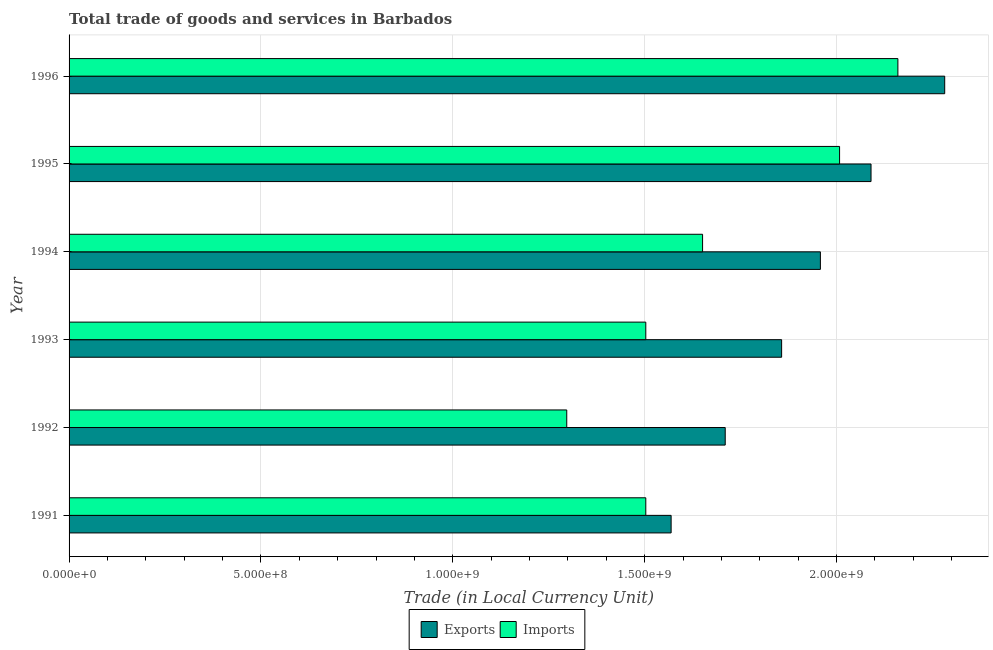How many groups of bars are there?
Offer a very short reply. 6. Are the number of bars per tick equal to the number of legend labels?
Your answer should be very brief. Yes. How many bars are there on the 1st tick from the top?
Give a very brief answer. 2. What is the label of the 3rd group of bars from the top?
Provide a short and direct response. 1994. In how many cases, is the number of bars for a given year not equal to the number of legend labels?
Make the answer very short. 0. What is the export of goods and services in 1993?
Your answer should be very brief. 1.86e+09. Across all years, what is the maximum imports of goods and services?
Give a very brief answer. 2.16e+09. Across all years, what is the minimum imports of goods and services?
Offer a very short reply. 1.30e+09. In which year was the export of goods and services maximum?
Give a very brief answer. 1996. In which year was the imports of goods and services minimum?
Keep it short and to the point. 1992. What is the total export of goods and services in the graph?
Your answer should be very brief. 1.15e+1. What is the difference between the imports of goods and services in 1991 and that in 1996?
Provide a short and direct response. -6.57e+08. What is the difference between the export of goods and services in 1992 and the imports of goods and services in 1996?
Provide a succinct answer. -4.50e+08. What is the average imports of goods and services per year?
Keep it short and to the point. 1.69e+09. In the year 1996, what is the difference between the imports of goods and services and export of goods and services?
Provide a succinct answer. -1.22e+08. In how many years, is the imports of goods and services greater than 2000000000 LCU?
Offer a terse response. 2. What is the ratio of the export of goods and services in 1991 to that in 1993?
Give a very brief answer. 0.84. What is the difference between the highest and the second highest export of goods and services?
Make the answer very short. 1.92e+08. What is the difference between the highest and the lowest export of goods and services?
Your answer should be compact. 7.13e+08. Is the sum of the export of goods and services in 1991 and 1995 greater than the maximum imports of goods and services across all years?
Your answer should be very brief. Yes. What does the 2nd bar from the top in 1992 represents?
Your answer should be compact. Exports. What does the 2nd bar from the bottom in 1995 represents?
Keep it short and to the point. Imports. Are all the bars in the graph horizontal?
Ensure brevity in your answer.  Yes. How many years are there in the graph?
Your response must be concise. 6. What is the difference between two consecutive major ticks on the X-axis?
Make the answer very short. 5.00e+08. Does the graph contain grids?
Ensure brevity in your answer.  Yes. Where does the legend appear in the graph?
Offer a terse response. Bottom center. How many legend labels are there?
Keep it short and to the point. 2. What is the title of the graph?
Provide a succinct answer. Total trade of goods and services in Barbados. Does "% of GNI" appear as one of the legend labels in the graph?
Your response must be concise. No. What is the label or title of the X-axis?
Make the answer very short. Trade (in Local Currency Unit). What is the label or title of the Y-axis?
Ensure brevity in your answer.  Year. What is the Trade (in Local Currency Unit) in Exports in 1991?
Give a very brief answer. 1.57e+09. What is the Trade (in Local Currency Unit) of Imports in 1991?
Provide a short and direct response. 1.50e+09. What is the Trade (in Local Currency Unit) in Exports in 1992?
Offer a terse response. 1.71e+09. What is the Trade (in Local Currency Unit) in Imports in 1992?
Give a very brief answer. 1.30e+09. What is the Trade (in Local Currency Unit) of Exports in 1993?
Ensure brevity in your answer.  1.86e+09. What is the Trade (in Local Currency Unit) in Imports in 1993?
Provide a short and direct response. 1.50e+09. What is the Trade (in Local Currency Unit) of Exports in 1994?
Your answer should be very brief. 1.96e+09. What is the Trade (in Local Currency Unit) of Imports in 1994?
Give a very brief answer. 1.65e+09. What is the Trade (in Local Currency Unit) of Exports in 1995?
Make the answer very short. 2.09e+09. What is the Trade (in Local Currency Unit) in Imports in 1995?
Provide a short and direct response. 2.01e+09. What is the Trade (in Local Currency Unit) of Exports in 1996?
Ensure brevity in your answer.  2.28e+09. What is the Trade (in Local Currency Unit) in Imports in 1996?
Offer a very short reply. 2.16e+09. Across all years, what is the maximum Trade (in Local Currency Unit) in Exports?
Your answer should be very brief. 2.28e+09. Across all years, what is the maximum Trade (in Local Currency Unit) of Imports?
Provide a succinct answer. 2.16e+09. Across all years, what is the minimum Trade (in Local Currency Unit) in Exports?
Your response must be concise. 1.57e+09. Across all years, what is the minimum Trade (in Local Currency Unit) in Imports?
Provide a short and direct response. 1.30e+09. What is the total Trade (in Local Currency Unit) of Exports in the graph?
Offer a very short reply. 1.15e+1. What is the total Trade (in Local Currency Unit) in Imports in the graph?
Provide a succinct answer. 1.01e+1. What is the difference between the Trade (in Local Currency Unit) of Exports in 1991 and that in 1992?
Offer a very short reply. -1.41e+08. What is the difference between the Trade (in Local Currency Unit) of Imports in 1991 and that in 1992?
Provide a short and direct response. 2.06e+08. What is the difference between the Trade (in Local Currency Unit) of Exports in 1991 and that in 1993?
Make the answer very short. -2.88e+08. What is the difference between the Trade (in Local Currency Unit) of Exports in 1991 and that in 1994?
Provide a short and direct response. -3.89e+08. What is the difference between the Trade (in Local Currency Unit) of Imports in 1991 and that in 1994?
Make the answer very short. -1.48e+08. What is the difference between the Trade (in Local Currency Unit) of Exports in 1991 and that in 1995?
Provide a short and direct response. -5.21e+08. What is the difference between the Trade (in Local Currency Unit) of Imports in 1991 and that in 1995?
Give a very brief answer. -5.05e+08. What is the difference between the Trade (in Local Currency Unit) in Exports in 1991 and that in 1996?
Make the answer very short. -7.13e+08. What is the difference between the Trade (in Local Currency Unit) in Imports in 1991 and that in 1996?
Give a very brief answer. -6.57e+08. What is the difference between the Trade (in Local Currency Unit) in Exports in 1992 and that in 1993?
Ensure brevity in your answer.  -1.47e+08. What is the difference between the Trade (in Local Currency Unit) of Imports in 1992 and that in 1993?
Ensure brevity in your answer.  -2.06e+08. What is the difference between the Trade (in Local Currency Unit) in Exports in 1992 and that in 1994?
Provide a short and direct response. -2.48e+08. What is the difference between the Trade (in Local Currency Unit) in Imports in 1992 and that in 1994?
Your answer should be very brief. -3.54e+08. What is the difference between the Trade (in Local Currency Unit) in Exports in 1992 and that in 1995?
Your response must be concise. -3.80e+08. What is the difference between the Trade (in Local Currency Unit) in Imports in 1992 and that in 1995?
Provide a succinct answer. -7.11e+08. What is the difference between the Trade (in Local Currency Unit) in Exports in 1992 and that in 1996?
Provide a succinct answer. -5.72e+08. What is the difference between the Trade (in Local Currency Unit) in Imports in 1992 and that in 1996?
Your answer should be compact. -8.63e+08. What is the difference between the Trade (in Local Currency Unit) in Exports in 1993 and that in 1994?
Provide a succinct answer. -1.01e+08. What is the difference between the Trade (in Local Currency Unit) of Imports in 1993 and that in 1994?
Your response must be concise. -1.48e+08. What is the difference between the Trade (in Local Currency Unit) in Exports in 1993 and that in 1995?
Your response must be concise. -2.33e+08. What is the difference between the Trade (in Local Currency Unit) of Imports in 1993 and that in 1995?
Give a very brief answer. -5.05e+08. What is the difference between the Trade (in Local Currency Unit) of Exports in 1993 and that in 1996?
Your response must be concise. -4.25e+08. What is the difference between the Trade (in Local Currency Unit) of Imports in 1993 and that in 1996?
Offer a very short reply. -6.57e+08. What is the difference between the Trade (in Local Currency Unit) of Exports in 1994 and that in 1995?
Offer a very short reply. -1.32e+08. What is the difference between the Trade (in Local Currency Unit) of Imports in 1994 and that in 1995?
Give a very brief answer. -3.57e+08. What is the difference between the Trade (in Local Currency Unit) of Exports in 1994 and that in 1996?
Offer a very short reply. -3.24e+08. What is the difference between the Trade (in Local Currency Unit) in Imports in 1994 and that in 1996?
Provide a succinct answer. -5.09e+08. What is the difference between the Trade (in Local Currency Unit) in Exports in 1995 and that in 1996?
Keep it short and to the point. -1.92e+08. What is the difference between the Trade (in Local Currency Unit) in Imports in 1995 and that in 1996?
Offer a terse response. -1.52e+08. What is the difference between the Trade (in Local Currency Unit) of Exports in 1991 and the Trade (in Local Currency Unit) of Imports in 1992?
Make the answer very short. 2.72e+08. What is the difference between the Trade (in Local Currency Unit) of Exports in 1991 and the Trade (in Local Currency Unit) of Imports in 1993?
Offer a terse response. 6.60e+07. What is the difference between the Trade (in Local Currency Unit) of Exports in 1991 and the Trade (in Local Currency Unit) of Imports in 1994?
Provide a short and direct response. -8.20e+07. What is the difference between the Trade (in Local Currency Unit) in Exports in 1991 and the Trade (in Local Currency Unit) in Imports in 1995?
Keep it short and to the point. -4.39e+08. What is the difference between the Trade (in Local Currency Unit) in Exports in 1991 and the Trade (in Local Currency Unit) in Imports in 1996?
Make the answer very short. -5.91e+08. What is the difference between the Trade (in Local Currency Unit) of Exports in 1992 and the Trade (in Local Currency Unit) of Imports in 1993?
Your response must be concise. 2.07e+08. What is the difference between the Trade (in Local Currency Unit) in Exports in 1992 and the Trade (in Local Currency Unit) in Imports in 1994?
Your answer should be very brief. 5.90e+07. What is the difference between the Trade (in Local Currency Unit) in Exports in 1992 and the Trade (in Local Currency Unit) in Imports in 1995?
Make the answer very short. -2.98e+08. What is the difference between the Trade (in Local Currency Unit) in Exports in 1992 and the Trade (in Local Currency Unit) in Imports in 1996?
Your answer should be compact. -4.50e+08. What is the difference between the Trade (in Local Currency Unit) in Exports in 1993 and the Trade (in Local Currency Unit) in Imports in 1994?
Your response must be concise. 2.06e+08. What is the difference between the Trade (in Local Currency Unit) of Exports in 1993 and the Trade (in Local Currency Unit) of Imports in 1995?
Your answer should be very brief. -1.51e+08. What is the difference between the Trade (in Local Currency Unit) of Exports in 1993 and the Trade (in Local Currency Unit) of Imports in 1996?
Provide a succinct answer. -3.03e+08. What is the difference between the Trade (in Local Currency Unit) in Exports in 1994 and the Trade (in Local Currency Unit) in Imports in 1995?
Ensure brevity in your answer.  -5.00e+07. What is the difference between the Trade (in Local Currency Unit) in Exports in 1994 and the Trade (in Local Currency Unit) in Imports in 1996?
Provide a succinct answer. -2.02e+08. What is the difference between the Trade (in Local Currency Unit) in Exports in 1995 and the Trade (in Local Currency Unit) in Imports in 1996?
Your answer should be compact. -7.00e+07. What is the average Trade (in Local Currency Unit) in Exports per year?
Your answer should be compact. 1.91e+09. What is the average Trade (in Local Currency Unit) in Imports per year?
Ensure brevity in your answer.  1.69e+09. In the year 1991, what is the difference between the Trade (in Local Currency Unit) in Exports and Trade (in Local Currency Unit) in Imports?
Your response must be concise. 6.60e+07. In the year 1992, what is the difference between the Trade (in Local Currency Unit) of Exports and Trade (in Local Currency Unit) of Imports?
Your response must be concise. 4.13e+08. In the year 1993, what is the difference between the Trade (in Local Currency Unit) of Exports and Trade (in Local Currency Unit) of Imports?
Give a very brief answer. 3.54e+08. In the year 1994, what is the difference between the Trade (in Local Currency Unit) in Exports and Trade (in Local Currency Unit) in Imports?
Offer a terse response. 3.07e+08. In the year 1995, what is the difference between the Trade (in Local Currency Unit) of Exports and Trade (in Local Currency Unit) of Imports?
Your answer should be compact. 8.20e+07. In the year 1996, what is the difference between the Trade (in Local Currency Unit) of Exports and Trade (in Local Currency Unit) of Imports?
Your response must be concise. 1.22e+08. What is the ratio of the Trade (in Local Currency Unit) in Exports in 1991 to that in 1992?
Offer a very short reply. 0.92. What is the ratio of the Trade (in Local Currency Unit) in Imports in 1991 to that in 1992?
Offer a terse response. 1.16. What is the ratio of the Trade (in Local Currency Unit) in Exports in 1991 to that in 1993?
Your answer should be compact. 0.84. What is the ratio of the Trade (in Local Currency Unit) in Imports in 1991 to that in 1993?
Give a very brief answer. 1. What is the ratio of the Trade (in Local Currency Unit) of Exports in 1991 to that in 1994?
Your answer should be compact. 0.8. What is the ratio of the Trade (in Local Currency Unit) of Imports in 1991 to that in 1994?
Provide a succinct answer. 0.91. What is the ratio of the Trade (in Local Currency Unit) of Exports in 1991 to that in 1995?
Your answer should be compact. 0.75. What is the ratio of the Trade (in Local Currency Unit) of Imports in 1991 to that in 1995?
Your answer should be compact. 0.75. What is the ratio of the Trade (in Local Currency Unit) of Exports in 1991 to that in 1996?
Your answer should be very brief. 0.69. What is the ratio of the Trade (in Local Currency Unit) of Imports in 1991 to that in 1996?
Your answer should be compact. 0.7. What is the ratio of the Trade (in Local Currency Unit) in Exports in 1992 to that in 1993?
Your answer should be compact. 0.92. What is the ratio of the Trade (in Local Currency Unit) of Imports in 1992 to that in 1993?
Offer a very short reply. 0.86. What is the ratio of the Trade (in Local Currency Unit) in Exports in 1992 to that in 1994?
Keep it short and to the point. 0.87. What is the ratio of the Trade (in Local Currency Unit) of Imports in 1992 to that in 1994?
Your answer should be very brief. 0.79. What is the ratio of the Trade (in Local Currency Unit) in Exports in 1992 to that in 1995?
Offer a very short reply. 0.82. What is the ratio of the Trade (in Local Currency Unit) in Imports in 1992 to that in 1995?
Provide a succinct answer. 0.65. What is the ratio of the Trade (in Local Currency Unit) in Exports in 1992 to that in 1996?
Your answer should be compact. 0.75. What is the ratio of the Trade (in Local Currency Unit) of Imports in 1992 to that in 1996?
Keep it short and to the point. 0.6. What is the ratio of the Trade (in Local Currency Unit) in Exports in 1993 to that in 1994?
Make the answer very short. 0.95. What is the ratio of the Trade (in Local Currency Unit) in Imports in 1993 to that in 1994?
Provide a short and direct response. 0.91. What is the ratio of the Trade (in Local Currency Unit) in Exports in 1993 to that in 1995?
Offer a very short reply. 0.89. What is the ratio of the Trade (in Local Currency Unit) in Imports in 1993 to that in 1995?
Your answer should be very brief. 0.75. What is the ratio of the Trade (in Local Currency Unit) of Exports in 1993 to that in 1996?
Your answer should be very brief. 0.81. What is the ratio of the Trade (in Local Currency Unit) of Imports in 1993 to that in 1996?
Ensure brevity in your answer.  0.7. What is the ratio of the Trade (in Local Currency Unit) in Exports in 1994 to that in 1995?
Your response must be concise. 0.94. What is the ratio of the Trade (in Local Currency Unit) in Imports in 1994 to that in 1995?
Offer a very short reply. 0.82. What is the ratio of the Trade (in Local Currency Unit) in Exports in 1994 to that in 1996?
Your response must be concise. 0.86. What is the ratio of the Trade (in Local Currency Unit) of Imports in 1994 to that in 1996?
Ensure brevity in your answer.  0.76. What is the ratio of the Trade (in Local Currency Unit) in Exports in 1995 to that in 1996?
Provide a succinct answer. 0.92. What is the ratio of the Trade (in Local Currency Unit) of Imports in 1995 to that in 1996?
Provide a succinct answer. 0.93. What is the difference between the highest and the second highest Trade (in Local Currency Unit) in Exports?
Your answer should be very brief. 1.92e+08. What is the difference between the highest and the second highest Trade (in Local Currency Unit) in Imports?
Your answer should be very brief. 1.52e+08. What is the difference between the highest and the lowest Trade (in Local Currency Unit) of Exports?
Offer a terse response. 7.13e+08. What is the difference between the highest and the lowest Trade (in Local Currency Unit) in Imports?
Provide a short and direct response. 8.63e+08. 